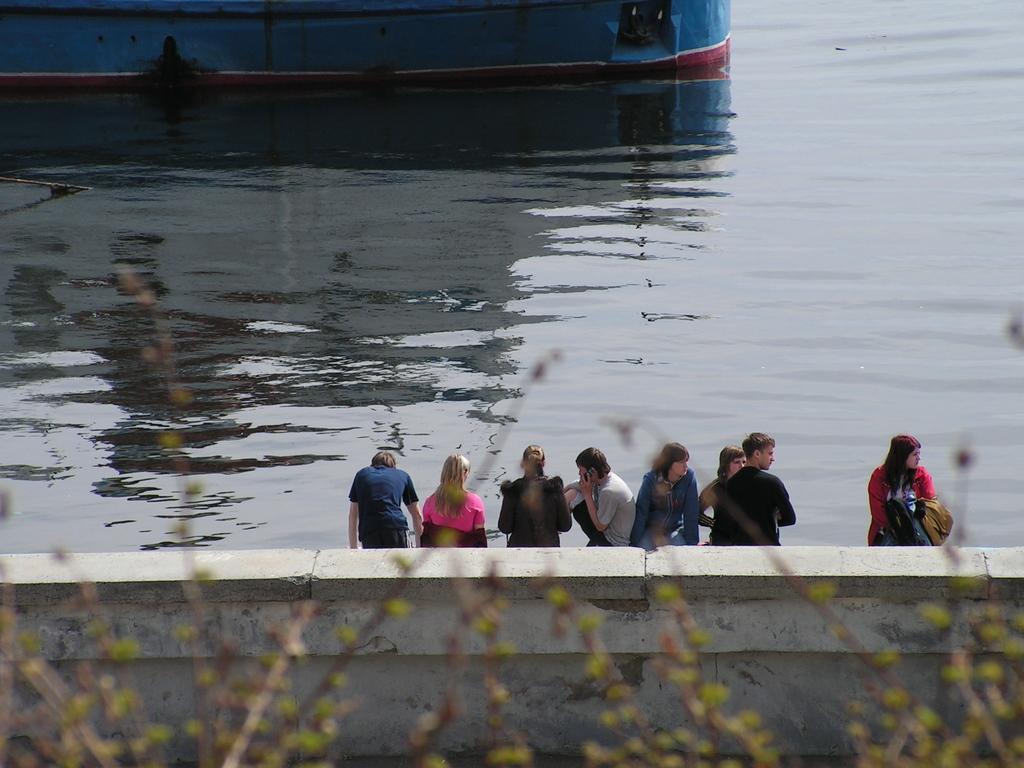How would you summarize this image in a sentence or two? In this image I can see few trees, the wall and few persons standing. In the background I can see the water and a blue, white and red colored object on the surface of the water. 